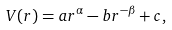<formula> <loc_0><loc_0><loc_500><loc_500>V ( r ) = a r ^ { \alpha } - b r ^ { - \beta } + c ,</formula> 